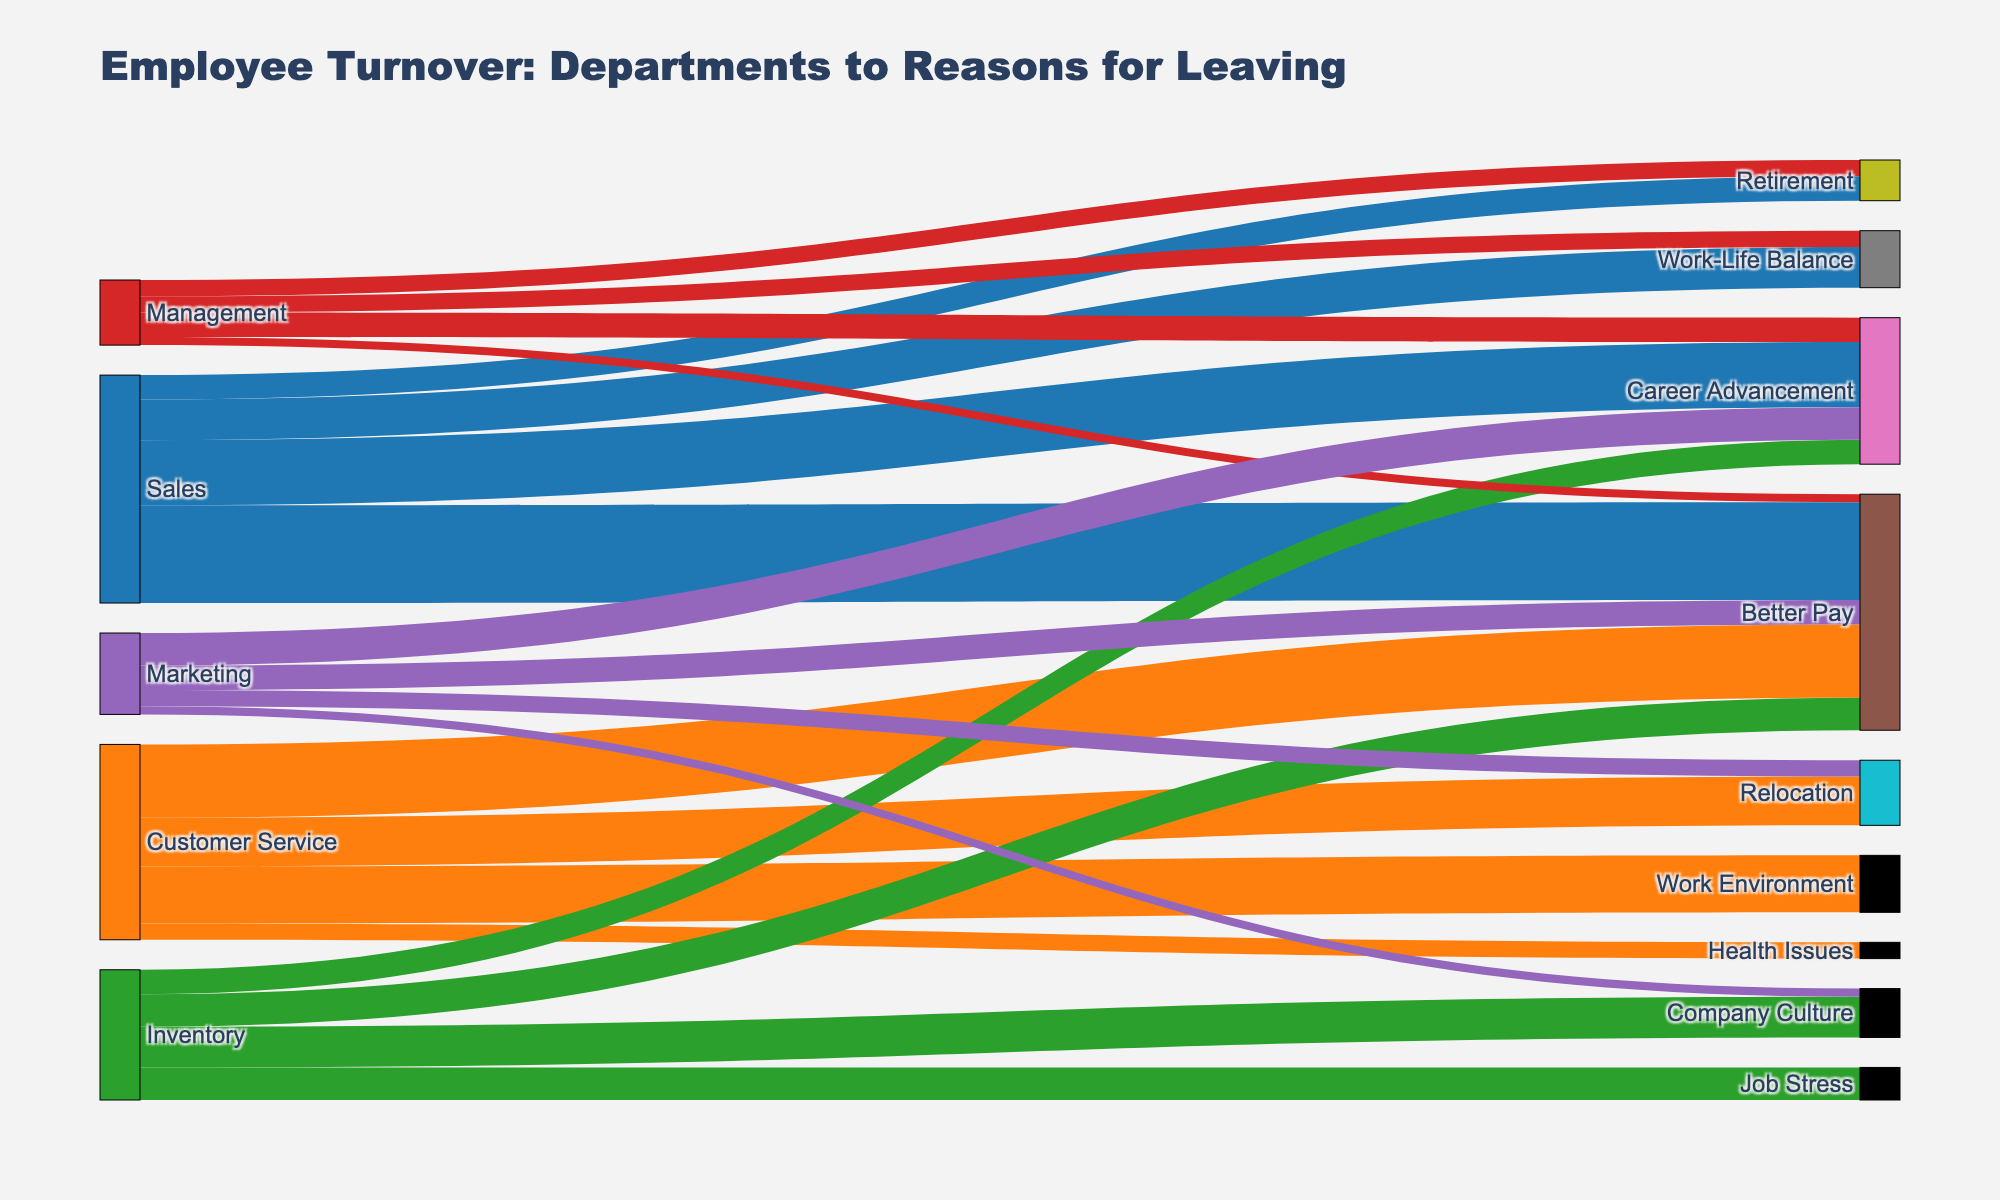What is the title of the Sankey diagram? The title of the Sankey diagram is displayed at the top and reads "Employee Turnover: Departments to Reasons for Leaving".
Answer: Employee Turnover: Departments to Reasons for Leaving How many unique reasons for leaving are shown in the diagram? By counting the number of different reasons listed in the data, we find there are 10 unique reasons: Better Pay, Career Advancement, Work-Life Balance, Retirement, Relocation, Work Environment, Health Issues, Company Culture, Job Stress.
Answer: 10 Which department has the highest number of employees leaving for "Better Pay"? By examining the thickness of the links from departments to "Better Pay", we see that Sales has 12 employees, Customer Service has 9, Inventory has 4, Management has 1, and Marketing has 3. Therefore, Sales has the highest number (12).
Answer: Sales What's the total number of employees that have left the Inventory department? Sum the numbers for all reasons in the Inventory department: Better Pay (4) + Career Advancement (3) + Company Culture (5) + Job Stress (4) = 16.
Answer: 16 Compare the number of employees who left for "Career Advancement" between the Sales and Marketing departments. In Sales, 8 employees left for Career Advancement, while in Marketing, 4 employees left for the same reason. Comparing these: 8 (Sales) is greater than 4 (Marketing).
Answer: Sales has more (8 vs 4) Which reason for leaving has the lowest number of employees across all departments? By summing up the numbers for each reason and comparing, Health Issues has the lowest number: only 2 employees from Customer Service.
Answer: Health Issues Calculate the total number of employees who left all departments for reasons related to pay (Better Pay). Sum the numbers for "Better Pay" from each department: Sales (12) + Customer Service (9) + Inventory (4) + Management (1) + Marketing (3) = 29.
Answer: 29 How many employees left the Sales department compared to the Customer Service department? Count the total number from Sales: Better Pay (12) + Career Advancement (8) + Work-Life Balance (5) + Retirement (3) = 28. Customer Service: Better Pay (9) + Relocation (6) + Work Environment (7) + Health Issues (2) = 24. Sales (28) is greater than Customer Service (24).
Answer: Sales has more (28 vs 24) What is the most common reason for leaving across all departments? By summing up the numbers for each reason and comparing, "Better Pay" has the highest total: 12 (Sales) + 9 (Customer Service) + 4 (Inventory) + 1 (Management) + 3 (Marketing) = 29.
Answer: Better Pay 